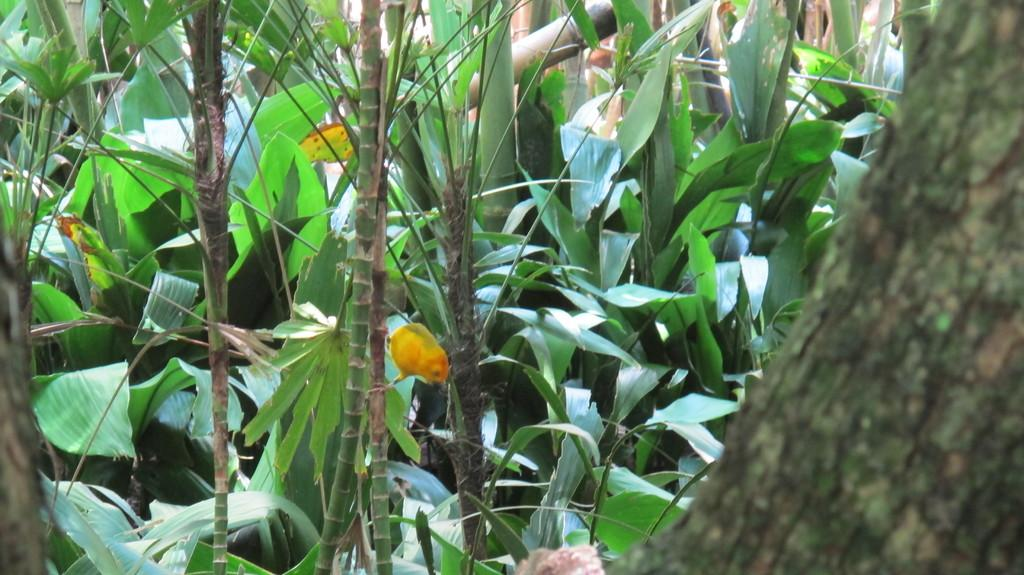What type of vegetation can be seen in the image? There are trees in the image. Can you see any planes flying over the trees in the image? There is no mention of planes in the image, so we cannot determine if any are present. 